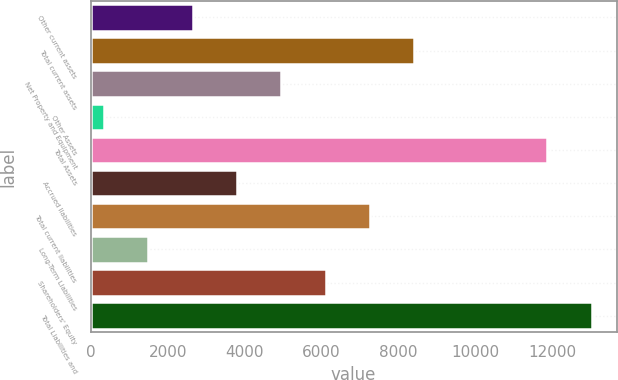<chart> <loc_0><loc_0><loc_500><loc_500><bar_chart><fcel>Other current assets<fcel>Total current assets<fcel>Net Property and Equipment<fcel>Other Assets<fcel>Total Assets<fcel>Accrued liabilities<fcel>Total current liabilities<fcel>Long-Term Liabilities<fcel>Shareholders' Equity<fcel>Total Liabilities and<nl><fcel>2651.2<fcel>8409.2<fcel>4954.4<fcel>348<fcel>11864<fcel>3802.8<fcel>7257.6<fcel>1499.6<fcel>6106<fcel>13015.6<nl></chart> 